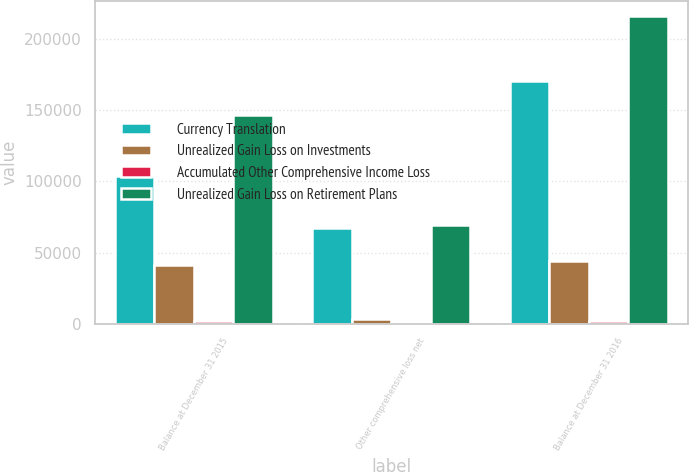Convert chart to OTSL. <chart><loc_0><loc_0><loc_500><loc_500><stacked_bar_chart><ecel><fcel>Balance at December 31 2015<fcel>Other comprehensive loss net<fcel>Balance at December 31 2016<nl><fcel>Currency Translation<fcel>103570<fcel>66996<fcel>170566<nl><fcel>Unrealized Gain Loss on Investments<fcel>40946<fcel>2948<fcel>43894<nl><fcel>Accumulated Other Comprehensive Income Loss<fcel>2210<fcel>390<fcel>1820<nl><fcel>Unrealized Gain Loss on Retirement Plans<fcel>146726<fcel>69554<fcel>216280<nl></chart> 